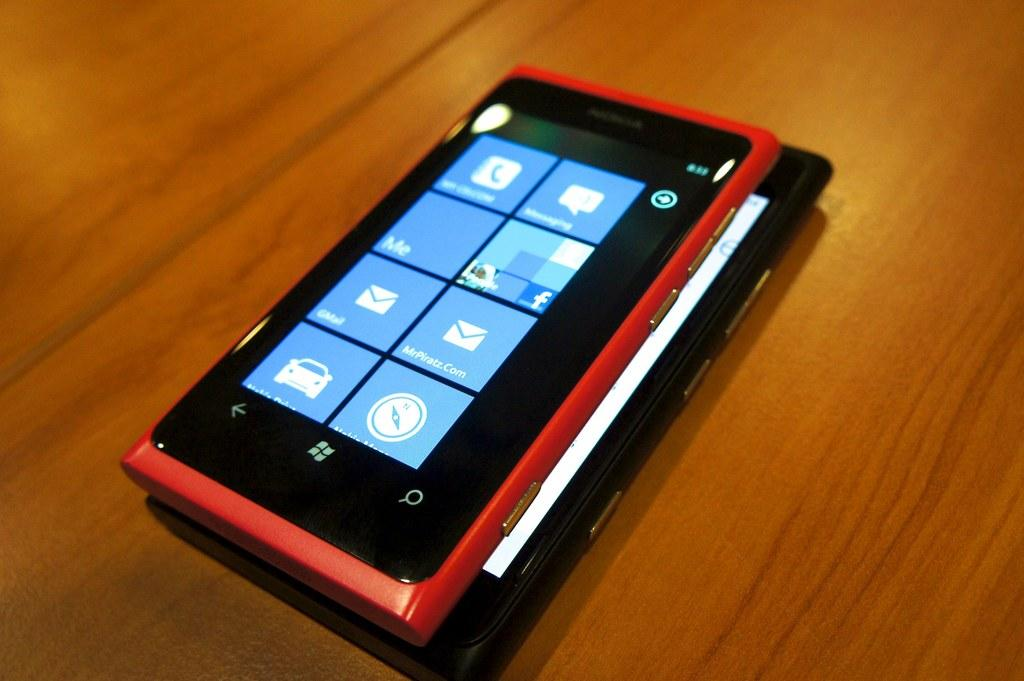<image>
Summarize the visual content of the image. An orange windows phone with the display showing apps such as mail and messaging. 